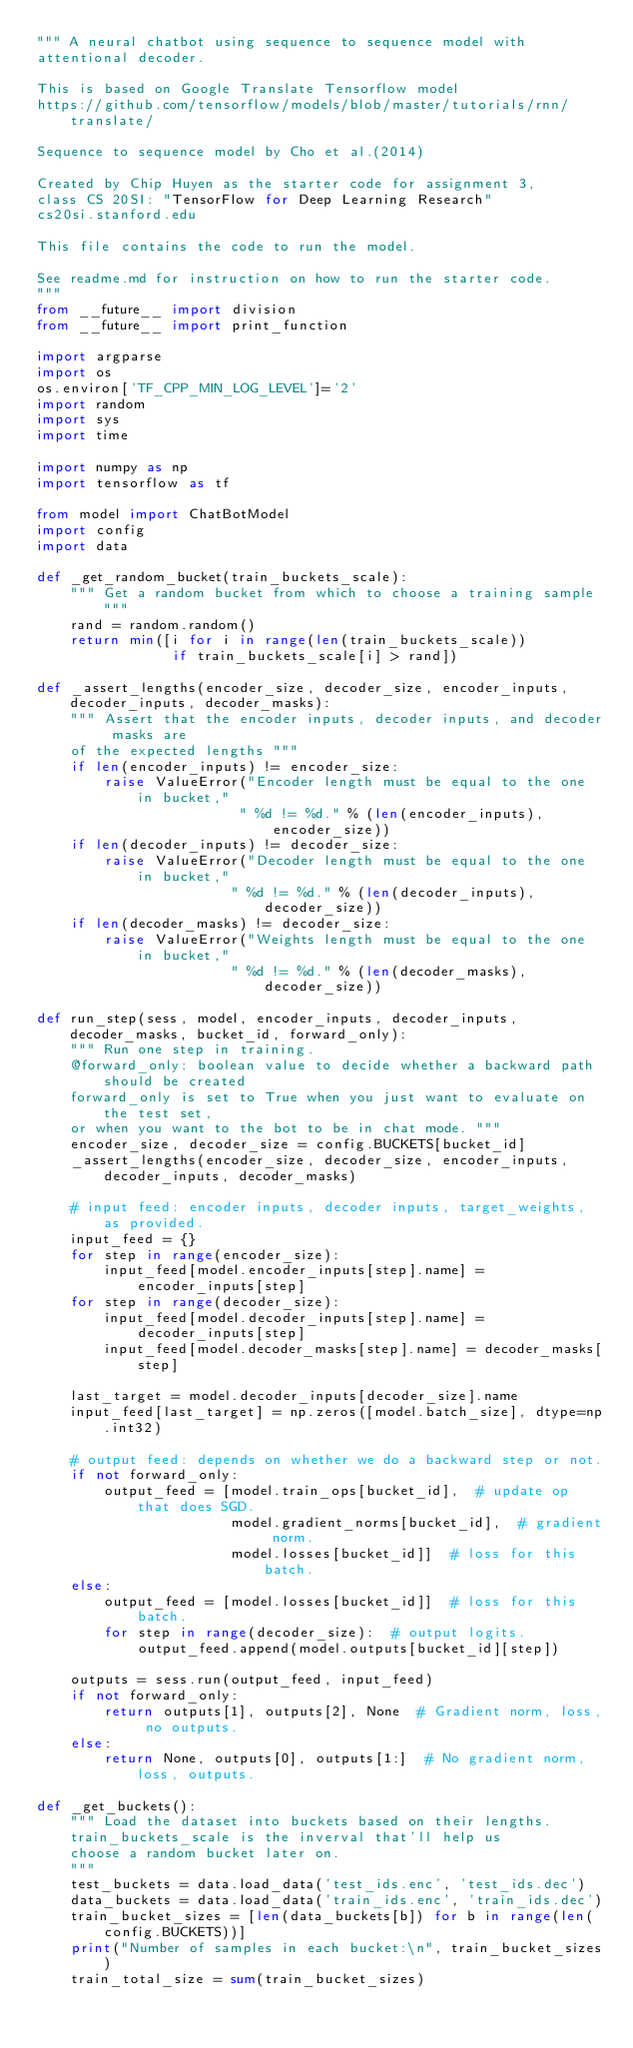Convert code to text. <code><loc_0><loc_0><loc_500><loc_500><_Python_>""" A neural chatbot using sequence to sequence model with
attentional decoder. 

This is based on Google Translate Tensorflow model 
https://github.com/tensorflow/models/blob/master/tutorials/rnn/translate/

Sequence to sequence model by Cho et al.(2014)

Created by Chip Huyen as the starter code for assignment 3,
class CS 20SI: "TensorFlow for Deep Learning Research"
cs20si.stanford.edu

This file contains the code to run the model.

See readme.md for instruction on how to run the starter code.
"""
from __future__ import division
from __future__ import print_function

import argparse
import os
os.environ['TF_CPP_MIN_LOG_LEVEL']='2'
import random
import sys
import time

import numpy as np
import tensorflow as tf

from model import ChatBotModel
import config
import data

def _get_random_bucket(train_buckets_scale):
    """ Get a random bucket from which to choose a training sample """
    rand = random.random()
    return min([i for i in range(len(train_buckets_scale))
                if train_buckets_scale[i] > rand])

def _assert_lengths(encoder_size, decoder_size, encoder_inputs, decoder_inputs, decoder_masks):
    """ Assert that the encoder inputs, decoder inputs, and decoder masks are
    of the expected lengths """
    if len(encoder_inputs) != encoder_size:
        raise ValueError("Encoder length must be equal to the one in bucket,"
                        " %d != %d." % (len(encoder_inputs), encoder_size))
    if len(decoder_inputs) != decoder_size:
        raise ValueError("Decoder length must be equal to the one in bucket,"
                       " %d != %d." % (len(decoder_inputs), decoder_size))
    if len(decoder_masks) != decoder_size:
        raise ValueError("Weights length must be equal to the one in bucket,"
                       " %d != %d." % (len(decoder_masks), decoder_size))

def run_step(sess, model, encoder_inputs, decoder_inputs, decoder_masks, bucket_id, forward_only):
    """ Run one step in training.
    @forward_only: boolean value to decide whether a backward path should be created
    forward_only is set to True when you just want to evaluate on the test set,
    or when you want to the bot to be in chat mode. """
    encoder_size, decoder_size = config.BUCKETS[bucket_id]
    _assert_lengths(encoder_size, decoder_size, encoder_inputs, decoder_inputs, decoder_masks)

    # input feed: encoder inputs, decoder inputs, target_weights, as provided.
    input_feed = {}
    for step in range(encoder_size):
        input_feed[model.encoder_inputs[step].name] = encoder_inputs[step]
    for step in range(decoder_size):
        input_feed[model.decoder_inputs[step].name] = decoder_inputs[step]
        input_feed[model.decoder_masks[step].name] = decoder_masks[step]

    last_target = model.decoder_inputs[decoder_size].name
    input_feed[last_target] = np.zeros([model.batch_size], dtype=np.int32)

    # output feed: depends on whether we do a backward step or not.
    if not forward_only:
        output_feed = [model.train_ops[bucket_id],  # update op that does SGD.
                       model.gradient_norms[bucket_id],  # gradient norm.
                       model.losses[bucket_id]]  # loss for this batch.
    else:
        output_feed = [model.losses[bucket_id]]  # loss for this batch.
        for step in range(decoder_size):  # output logits.
            output_feed.append(model.outputs[bucket_id][step])

    outputs = sess.run(output_feed, input_feed)
    if not forward_only:
        return outputs[1], outputs[2], None  # Gradient norm, loss, no outputs.
    else:
        return None, outputs[0], outputs[1:]  # No gradient norm, loss, outputs.

def _get_buckets():
    """ Load the dataset into buckets based on their lengths.
    train_buckets_scale is the inverval that'll help us 
    choose a random bucket later on.
    """
    test_buckets = data.load_data('test_ids.enc', 'test_ids.dec')
    data_buckets = data.load_data('train_ids.enc', 'train_ids.dec')
    train_bucket_sizes = [len(data_buckets[b]) for b in range(len(config.BUCKETS))]
    print("Number of samples in each bucket:\n", train_bucket_sizes)
    train_total_size = sum(train_bucket_sizes)</code> 